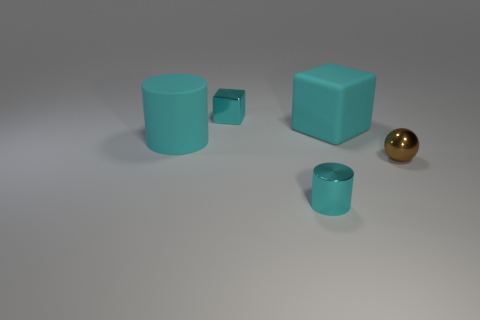Do the big cylinder and the big cube have the same material?
Your response must be concise. Yes. How many objects are gray rubber things or big matte things?
Your answer should be very brief. 2. What number of tiny brown objects have the same material as the tiny ball?
Your response must be concise. 0. Are there any tiny brown things to the left of the brown sphere?
Offer a terse response. No. What is the small cyan cylinder made of?
Offer a terse response. Metal. There is a tiny metal object in front of the small ball; does it have the same color as the large cylinder?
Ensure brevity in your answer.  Yes. Is there anything else that has the same shape as the brown metal thing?
Provide a short and direct response. No. What material is the cyan cylinder behind the small brown shiny ball?
Ensure brevity in your answer.  Rubber. The small metallic cylinder has what color?
Provide a short and direct response. Cyan. There is a metal thing behind the cyan rubber cylinder; does it have the same size as the small cyan cylinder?
Provide a short and direct response. Yes. 